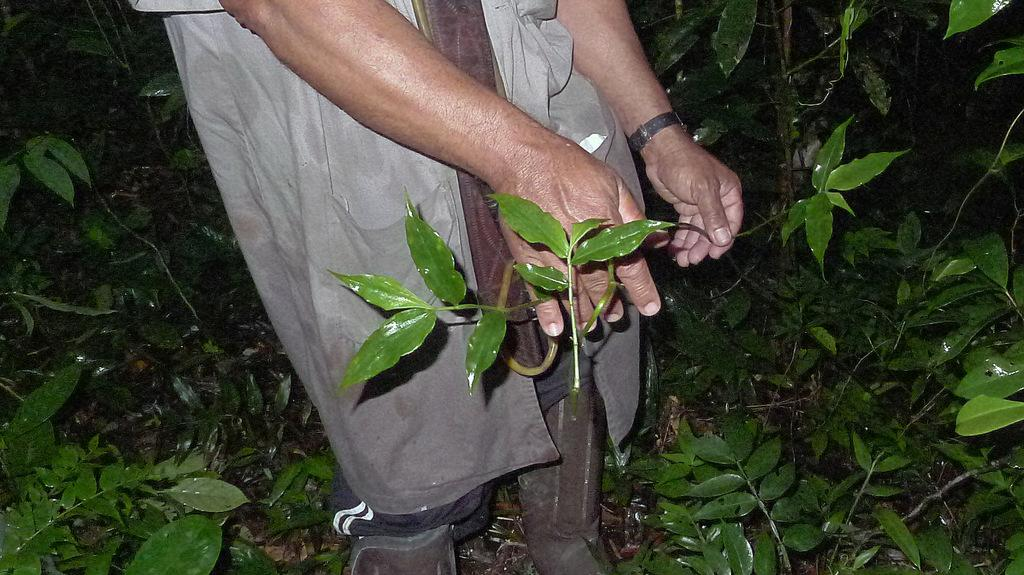Who or what is present in the image? There is a person in the image. What is the person doing in the image? The person is holding the stem of a plant. Are there any other plants visible in the image? Yes, there are plants in the image. How does the person compare to the silver hourglass in the image? There is no silver hourglass present in the image, so it cannot be compared to the person. 